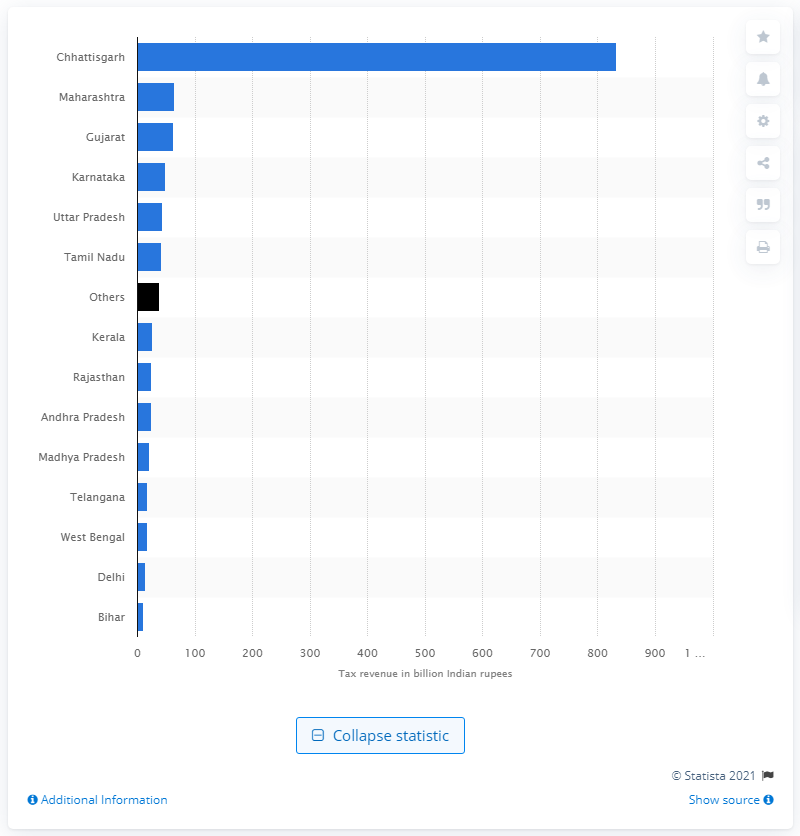Mention a couple of crucial points in this snapshot. The state of Chhattisgarh had the highest motor vehicle tax revenue at the end of the fiscal year 2016 among all Indian states. At the end of the fiscal year 2016, Chhattisgarh's motor vehicle tax revenue was Rs. 832.71 crore. 